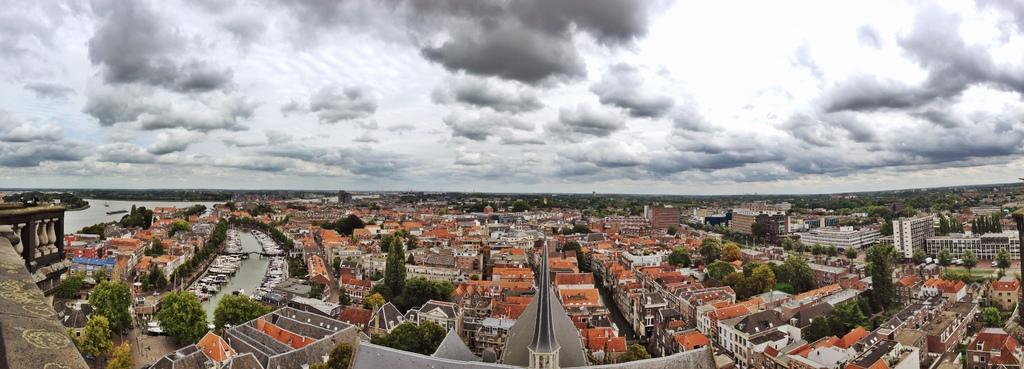What type of structures can be seen in the image? There are buildings in the image. What other natural elements are present in the image? There are trees in the image. What is visible in the background of the image? The sky is visible in the image. What can be seen on the left side of the image? There is water on the left side of the image, and there are boats in the water. Can you tell me how many bushes are depicted in the image? There are no bushes present in the image. What color is the father's hat in the image? There is no father present in the image. 